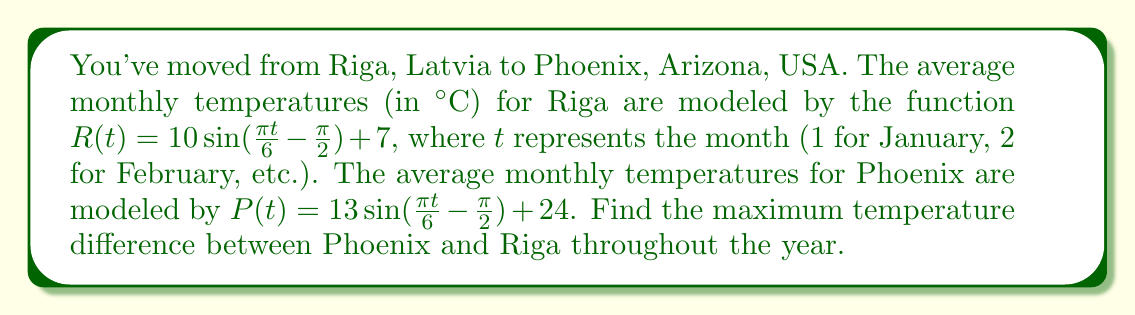Show me your answer to this math problem. To find the maximum temperature difference, we need to follow these steps:

1) The temperature difference function is:
   $D(t) = P(t) - R(t)$
   $D(t) = [13 \sin(\frac{\pi t}{6} - \frac{\pi}{2}) + 24] - [10 \sin(\frac{\pi t}{6} - \frac{\pi}{2}) + 7]$

2) Simplify:
   $D(t) = 3 \sin(\frac{\pi t}{6} - \frac{\pi}{2}) + 17$

3) To find the maximum, we need to find where the derivative of $D(t)$ is zero:
   $D'(t) = 3 \cdot \frac{\pi}{6} \cos(\frac{\pi t}{6} - \frac{\pi}{2}) = \frac{\pi}{2} \cos(\frac{\pi t}{6} - \frac{\pi}{2})$

4) Set $D'(t) = 0$:
   $\frac{\pi}{2} \cos(\frac{\pi t}{6} - \frac{\pi}{2}) = 0$
   $\cos(\frac{\pi t}{6} - \frac{\pi}{2}) = 0$

5) Solve:
   $\frac{\pi t}{6} - \frac{\pi}{2} = \frac{\pi}{2}$ (cosine is zero at $\frac{\pi}{2}$)
   $\frac{\pi t}{6} = \pi$
   $t = 6$

6) The maximum occurs at $t = 6$ (June). Calculate the maximum difference:
   $D(6) = 3 \sin(\frac{\pi \cdot 6}{6} - \frac{\pi}{2}) + 17 = 3 \sin(\pi - \frac{\pi}{2}) + 17 = 3 + 17 = 20$

Therefore, the maximum temperature difference is 20°C, occurring in June.
Answer: 20°C 